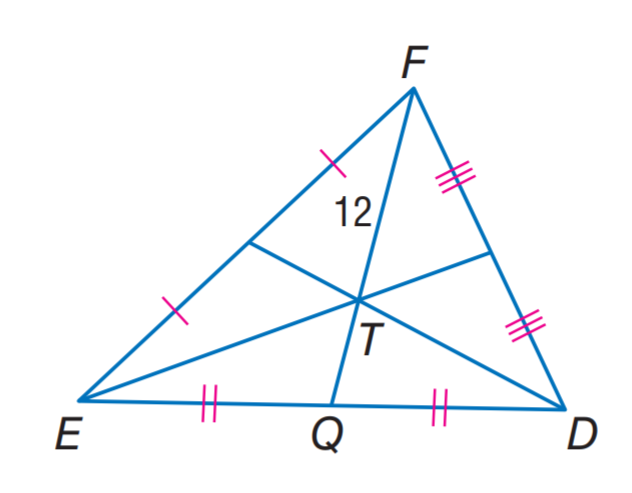Answer the mathemtical geometry problem and directly provide the correct option letter.
Question: In \triangle E D F, T is the centroid and F T = 12. Find T Q.
Choices: A: 3 B: 6 C: 12 D: 24 B 